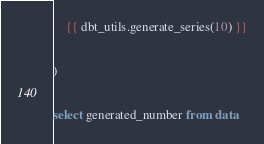Convert code to text. <code><loc_0><loc_0><loc_500><loc_500><_SQL_>    {{ dbt_utils.generate_series(10) }}

)

select generated_number from data
</code> 